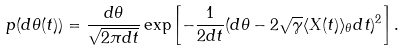<formula> <loc_0><loc_0><loc_500><loc_500>p ( d \theta ( t ) ) = \frac { d \theta } { \sqrt { 2 \pi d t } } \exp \left [ - \frac { 1 } { 2 d t } ( d \theta - 2 \sqrt { \gamma } \langle X ( t ) \rangle _ { \theta } d t ) ^ { 2 } \right ] .</formula> 